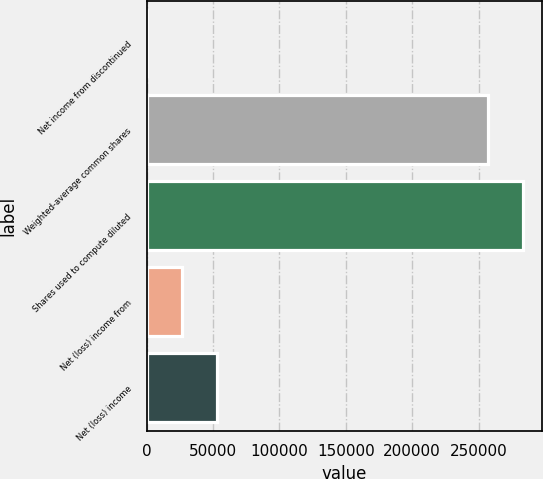Convert chart. <chart><loc_0><loc_0><loc_500><loc_500><bar_chart><fcel>Net income from discontinued<fcel>Weighted-average common shares<fcel>Shares used to compute diluted<fcel>Net (loss) income from<fcel>Net (loss) income<nl><fcel>0.06<fcel>257368<fcel>283737<fcel>26369<fcel>52737.8<nl></chart> 